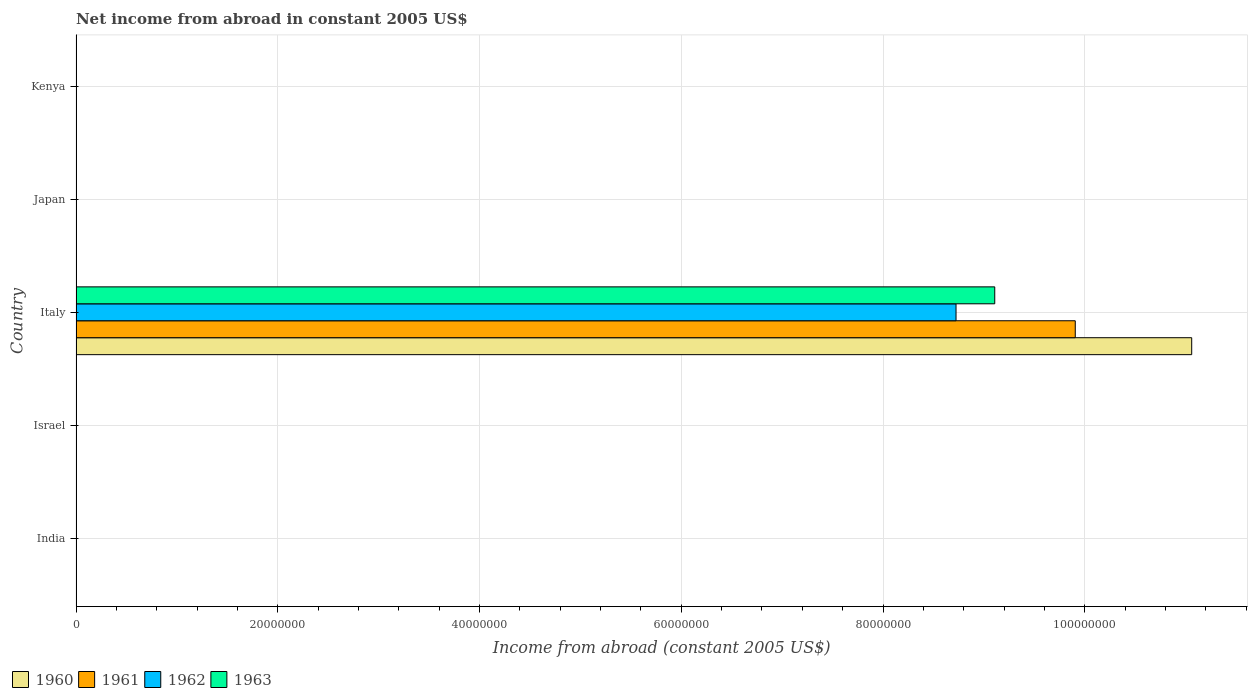How many different coloured bars are there?
Ensure brevity in your answer.  4. Are the number of bars per tick equal to the number of legend labels?
Offer a very short reply. No. How many bars are there on the 2nd tick from the top?
Offer a terse response. 0. What is the label of the 1st group of bars from the top?
Give a very brief answer. Kenya. In how many cases, is the number of bars for a given country not equal to the number of legend labels?
Keep it short and to the point. 4. What is the net income from abroad in 1962 in Italy?
Provide a short and direct response. 8.72e+07. Across all countries, what is the maximum net income from abroad in 1963?
Ensure brevity in your answer.  9.11e+07. Across all countries, what is the minimum net income from abroad in 1963?
Give a very brief answer. 0. What is the total net income from abroad in 1963 in the graph?
Provide a succinct answer. 9.11e+07. What is the difference between the net income from abroad in 1962 in Italy and the net income from abroad in 1963 in Israel?
Provide a short and direct response. 8.72e+07. What is the average net income from abroad in 1963 per country?
Provide a succinct answer. 1.82e+07. What is the difference between the net income from abroad in 1961 and net income from abroad in 1960 in Italy?
Your response must be concise. -1.15e+07. What is the difference between the highest and the lowest net income from abroad in 1961?
Provide a succinct answer. 9.91e+07. In how many countries, is the net income from abroad in 1961 greater than the average net income from abroad in 1961 taken over all countries?
Provide a succinct answer. 1. Is it the case that in every country, the sum of the net income from abroad in 1963 and net income from abroad in 1961 is greater than the sum of net income from abroad in 1960 and net income from abroad in 1962?
Offer a very short reply. No. Is it the case that in every country, the sum of the net income from abroad in 1960 and net income from abroad in 1962 is greater than the net income from abroad in 1961?
Your answer should be compact. No. How many bars are there?
Your answer should be compact. 4. Are all the bars in the graph horizontal?
Your answer should be very brief. Yes. How many countries are there in the graph?
Make the answer very short. 5. What is the difference between two consecutive major ticks on the X-axis?
Keep it short and to the point. 2.00e+07. Are the values on the major ticks of X-axis written in scientific E-notation?
Keep it short and to the point. No. Does the graph contain grids?
Keep it short and to the point. Yes. Where does the legend appear in the graph?
Keep it short and to the point. Bottom left. What is the title of the graph?
Make the answer very short. Net income from abroad in constant 2005 US$. What is the label or title of the X-axis?
Give a very brief answer. Income from abroad (constant 2005 US$). What is the Income from abroad (constant 2005 US$) in 1960 in India?
Ensure brevity in your answer.  0. What is the Income from abroad (constant 2005 US$) in 1962 in Israel?
Offer a terse response. 0. What is the Income from abroad (constant 2005 US$) of 1960 in Italy?
Your answer should be very brief. 1.11e+08. What is the Income from abroad (constant 2005 US$) of 1961 in Italy?
Offer a terse response. 9.91e+07. What is the Income from abroad (constant 2005 US$) in 1962 in Italy?
Your answer should be very brief. 8.72e+07. What is the Income from abroad (constant 2005 US$) of 1963 in Italy?
Your response must be concise. 9.11e+07. What is the Income from abroad (constant 2005 US$) of 1962 in Japan?
Offer a very short reply. 0. What is the Income from abroad (constant 2005 US$) of 1963 in Kenya?
Make the answer very short. 0. Across all countries, what is the maximum Income from abroad (constant 2005 US$) of 1960?
Keep it short and to the point. 1.11e+08. Across all countries, what is the maximum Income from abroad (constant 2005 US$) of 1961?
Your answer should be compact. 9.91e+07. Across all countries, what is the maximum Income from abroad (constant 2005 US$) of 1962?
Your response must be concise. 8.72e+07. Across all countries, what is the maximum Income from abroad (constant 2005 US$) in 1963?
Give a very brief answer. 9.11e+07. Across all countries, what is the minimum Income from abroad (constant 2005 US$) of 1961?
Make the answer very short. 0. Across all countries, what is the minimum Income from abroad (constant 2005 US$) in 1962?
Offer a terse response. 0. What is the total Income from abroad (constant 2005 US$) in 1960 in the graph?
Provide a short and direct response. 1.11e+08. What is the total Income from abroad (constant 2005 US$) of 1961 in the graph?
Offer a very short reply. 9.91e+07. What is the total Income from abroad (constant 2005 US$) of 1962 in the graph?
Offer a very short reply. 8.72e+07. What is the total Income from abroad (constant 2005 US$) in 1963 in the graph?
Provide a short and direct response. 9.11e+07. What is the average Income from abroad (constant 2005 US$) of 1960 per country?
Offer a terse response. 2.21e+07. What is the average Income from abroad (constant 2005 US$) in 1961 per country?
Your answer should be very brief. 1.98e+07. What is the average Income from abroad (constant 2005 US$) in 1962 per country?
Ensure brevity in your answer.  1.74e+07. What is the average Income from abroad (constant 2005 US$) of 1963 per country?
Ensure brevity in your answer.  1.82e+07. What is the difference between the Income from abroad (constant 2005 US$) in 1960 and Income from abroad (constant 2005 US$) in 1961 in Italy?
Provide a short and direct response. 1.15e+07. What is the difference between the Income from abroad (constant 2005 US$) in 1960 and Income from abroad (constant 2005 US$) in 1962 in Italy?
Provide a short and direct response. 2.34e+07. What is the difference between the Income from abroad (constant 2005 US$) in 1960 and Income from abroad (constant 2005 US$) in 1963 in Italy?
Ensure brevity in your answer.  1.95e+07. What is the difference between the Income from abroad (constant 2005 US$) of 1961 and Income from abroad (constant 2005 US$) of 1962 in Italy?
Keep it short and to the point. 1.18e+07. What is the difference between the Income from abroad (constant 2005 US$) of 1961 and Income from abroad (constant 2005 US$) of 1963 in Italy?
Your response must be concise. 7.98e+06. What is the difference between the Income from abroad (constant 2005 US$) of 1962 and Income from abroad (constant 2005 US$) of 1963 in Italy?
Your answer should be compact. -3.84e+06. What is the difference between the highest and the lowest Income from abroad (constant 2005 US$) in 1960?
Offer a terse response. 1.11e+08. What is the difference between the highest and the lowest Income from abroad (constant 2005 US$) of 1961?
Keep it short and to the point. 9.91e+07. What is the difference between the highest and the lowest Income from abroad (constant 2005 US$) in 1962?
Offer a very short reply. 8.72e+07. What is the difference between the highest and the lowest Income from abroad (constant 2005 US$) in 1963?
Keep it short and to the point. 9.11e+07. 